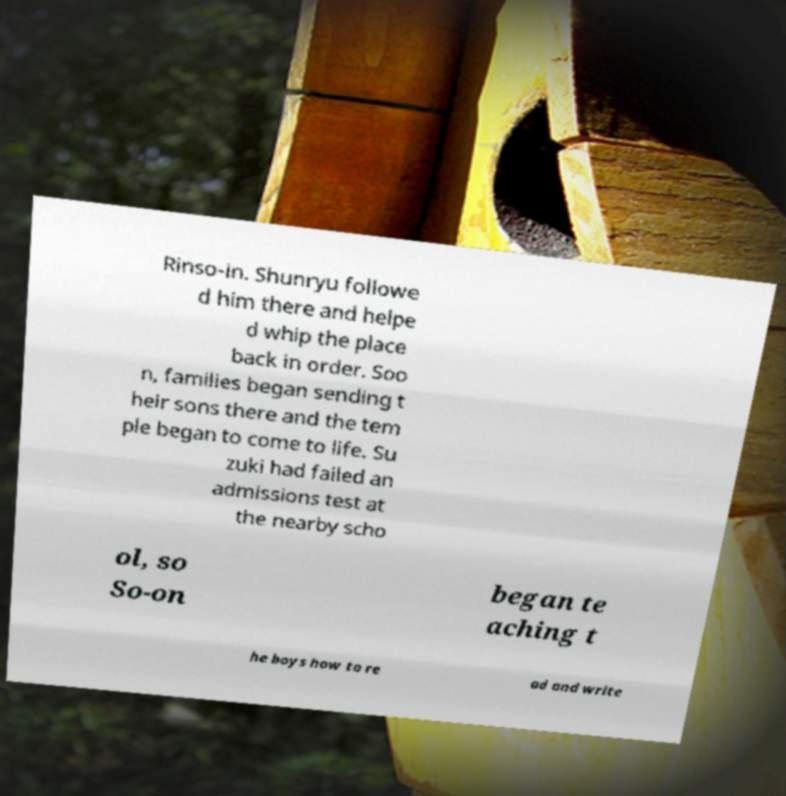What messages or text are displayed in this image? I need them in a readable, typed format. Rinso-in. Shunryu followe d him there and helpe d whip the place back in order. Soo n, families began sending t heir sons there and the tem ple began to come to life. Su zuki had failed an admissions test at the nearby scho ol, so So-on began te aching t he boys how to re ad and write 